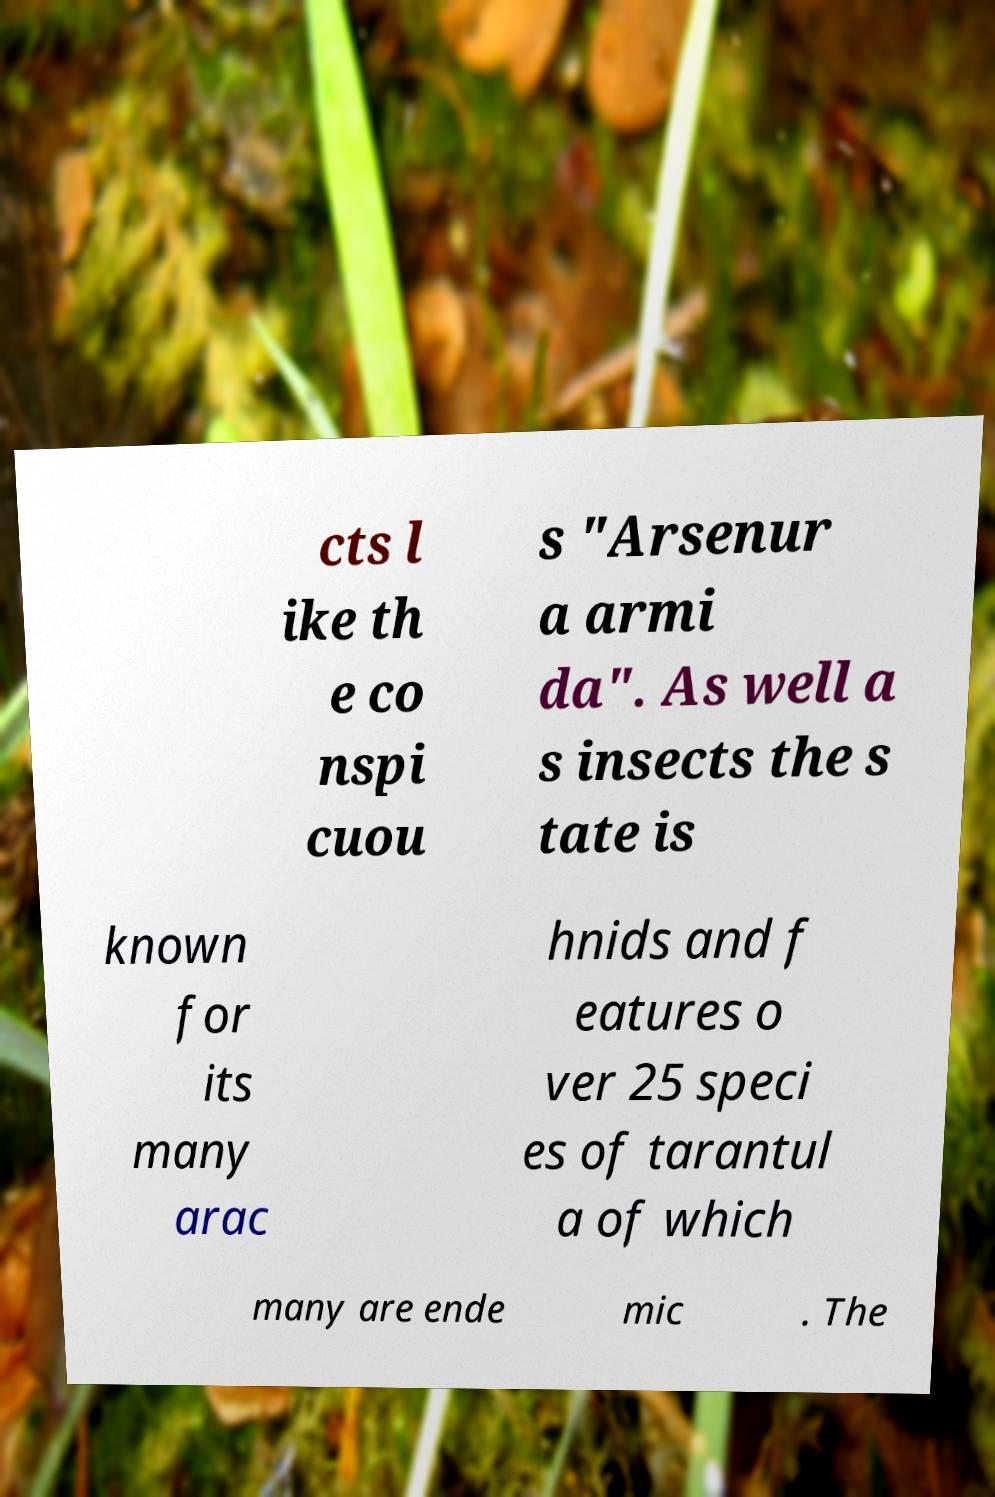Could you extract and type out the text from this image? cts l ike th e co nspi cuou s "Arsenur a armi da". As well a s insects the s tate is known for its many arac hnids and f eatures o ver 25 speci es of tarantul a of which many are ende mic . The 